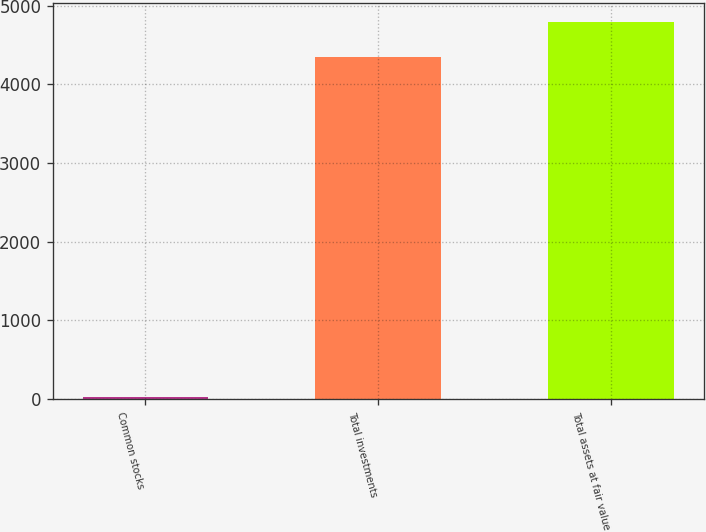Convert chart. <chart><loc_0><loc_0><loc_500><loc_500><bar_chart><fcel>Common stocks<fcel>Total investments<fcel>Total assets at fair value<nl><fcel>25<fcel>4355<fcel>4792.1<nl></chart> 